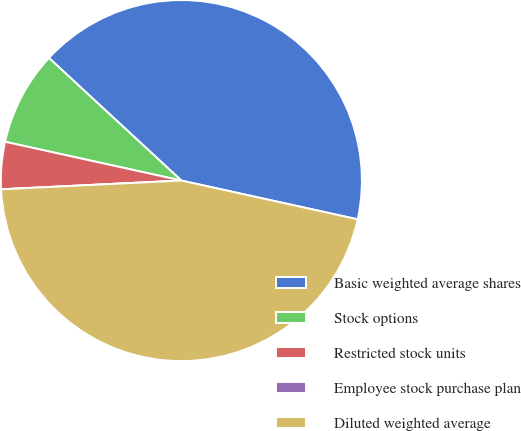<chart> <loc_0><loc_0><loc_500><loc_500><pie_chart><fcel>Basic weighted average shares<fcel>Stock options<fcel>Restricted stock units<fcel>Employee stock purchase plan<fcel>Diluted weighted average<nl><fcel>41.56%<fcel>8.44%<fcel>4.22%<fcel>0.0%<fcel>45.78%<nl></chart> 